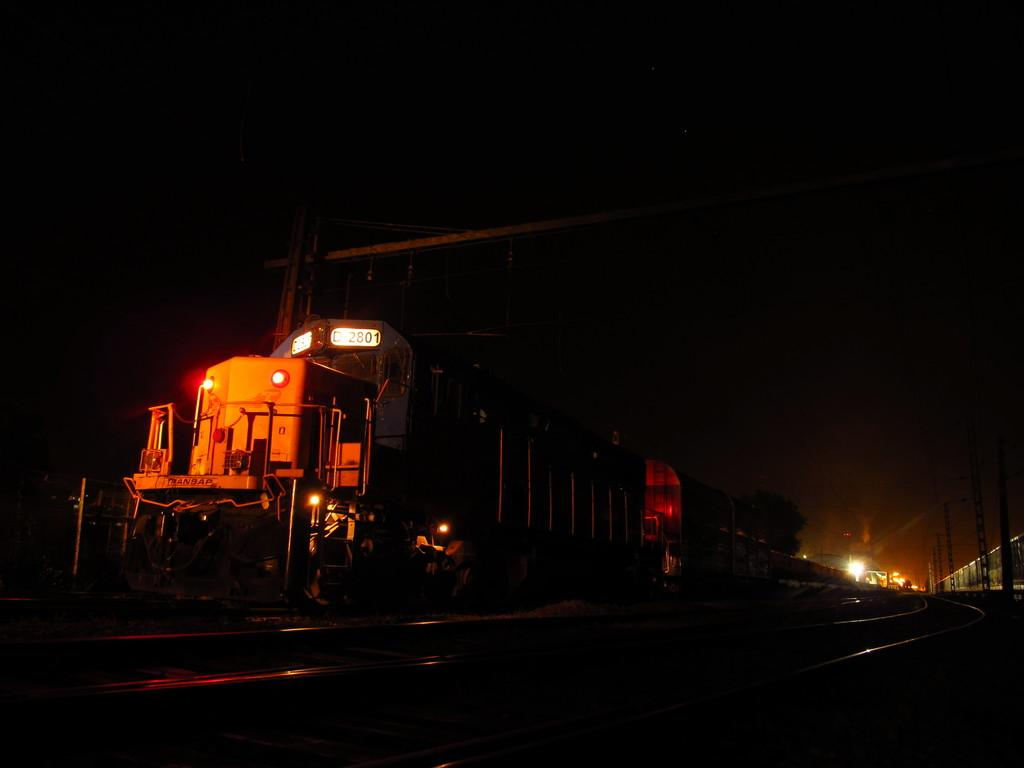What is the main subject in the center of the image? There is a train in the center of the image. What features are present in the center of the image along with the train? There are lights and railway tracks in the center of the image, as well as other objects. Can you describe the background of the image? In the background of the image, there are lights, poles, another train, and other objects. What type of celery is being used as a shock absorber for the train in the image? There is no celery present in the image, nor is there any indication that celery is being used as a shock absorber for the train. 